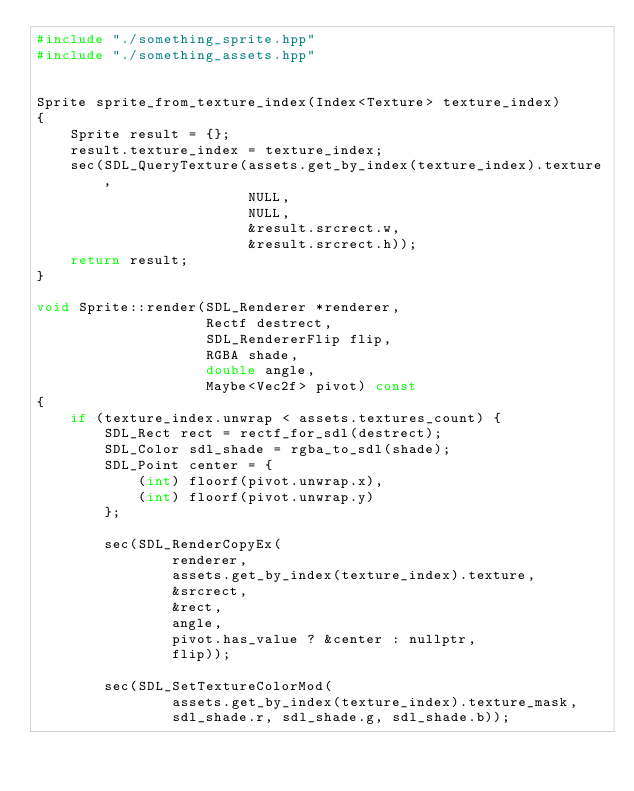<code> <loc_0><loc_0><loc_500><loc_500><_C++_>#include "./something_sprite.hpp"
#include "./something_assets.hpp"


Sprite sprite_from_texture_index(Index<Texture> texture_index)
{
    Sprite result = {};
    result.texture_index = texture_index;
    sec(SDL_QueryTexture(assets.get_by_index(texture_index).texture,
                         NULL,
                         NULL,
                         &result.srcrect.w,
                         &result.srcrect.h));
    return result;
}

void Sprite::render(SDL_Renderer *renderer,
                    Rectf destrect,
                    SDL_RendererFlip flip,
                    RGBA shade,
                    double angle,
                    Maybe<Vec2f> pivot) const
{
    if (texture_index.unwrap < assets.textures_count) {
        SDL_Rect rect = rectf_for_sdl(destrect);
        SDL_Color sdl_shade = rgba_to_sdl(shade);
        SDL_Point center = {
            (int) floorf(pivot.unwrap.x),
            (int) floorf(pivot.unwrap.y)
        };

        sec(SDL_RenderCopyEx(
                renderer,
                assets.get_by_index(texture_index).texture,
                &srcrect,
                &rect,
                angle,
                pivot.has_value ? &center : nullptr,
                flip));

        sec(SDL_SetTextureColorMod(
                assets.get_by_index(texture_index).texture_mask,
                sdl_shade.r, sdl_shade.g, sdl_shade.b));</code> 